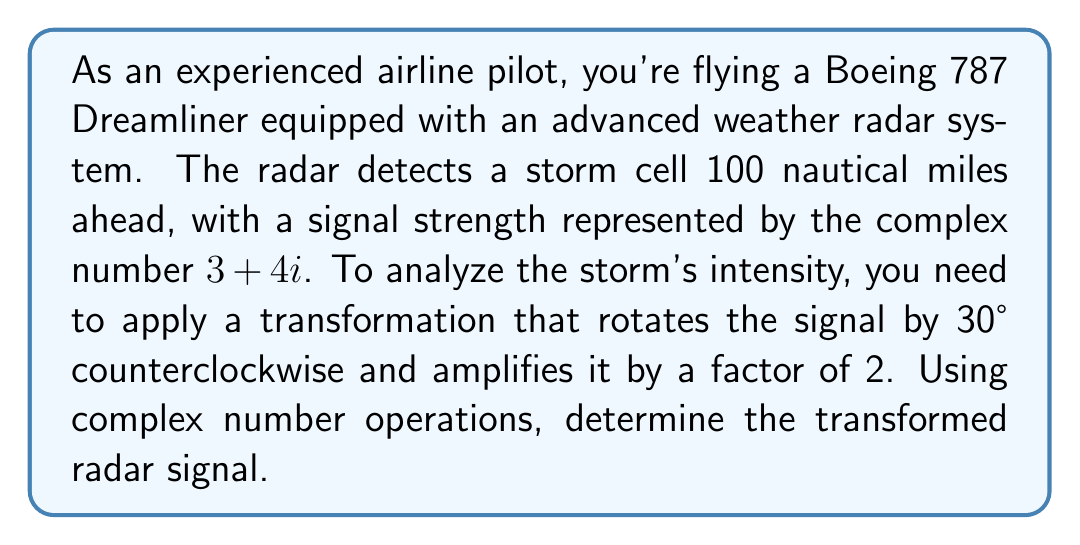Can you solve this math problem? Let's approach this step-by-step:

1) The original signal is represented by the complex number $z = 3 + 4i$.

2) To rotate a complex number by an angle $\theta$ counterclockwise, we multiply it by $e^{i\theta}$. In this case, $\theta = 30° = \frac{\pi}{6}$ radians.

3) To amplify the signal by a factor of 2, we multiply the result by 2.

4) Therefore, the transformation can be represented as:

   $$z_{new} = 2 \cdot z \cdot e^{i\frac{\pi}{6}}$$

5) We know that $e^{i\theta} = \cos\theta + i\sin\theta$. So:

   $$e^{i\frac{\pi}{6}} = \cos\frac{\pi}{6} + i\sin\frac{\pi}{6} = \frac{\sqrt{3}}{2} + \frac{1}{2}i$$

6) Now we can calculate:

   $$\begin{align}
   z_{new} &= 2 \cdot (3+4i) \cdot (\frac{\sqrt{3}}{2} + \frac{1}{2}i) \\
   &= (6+8i) \cdot (\frac{\sqrt{3}}{2} + \frac{1}{2}i) \\
   &= (3\sqrt{3} + 3) + (3 + 4\sqrt{3})i
   \end{align}$$

7) Simplifying:

   $$z_{new} = (3\sqrt{3} + 3) + (3 + 4\sqrt{3})i$$

This is the transformed radar signal.
Answer: The transformed radar signal is $(3\sqrt{3} + 3) + (3 + 4\sqrt{3})i$. 